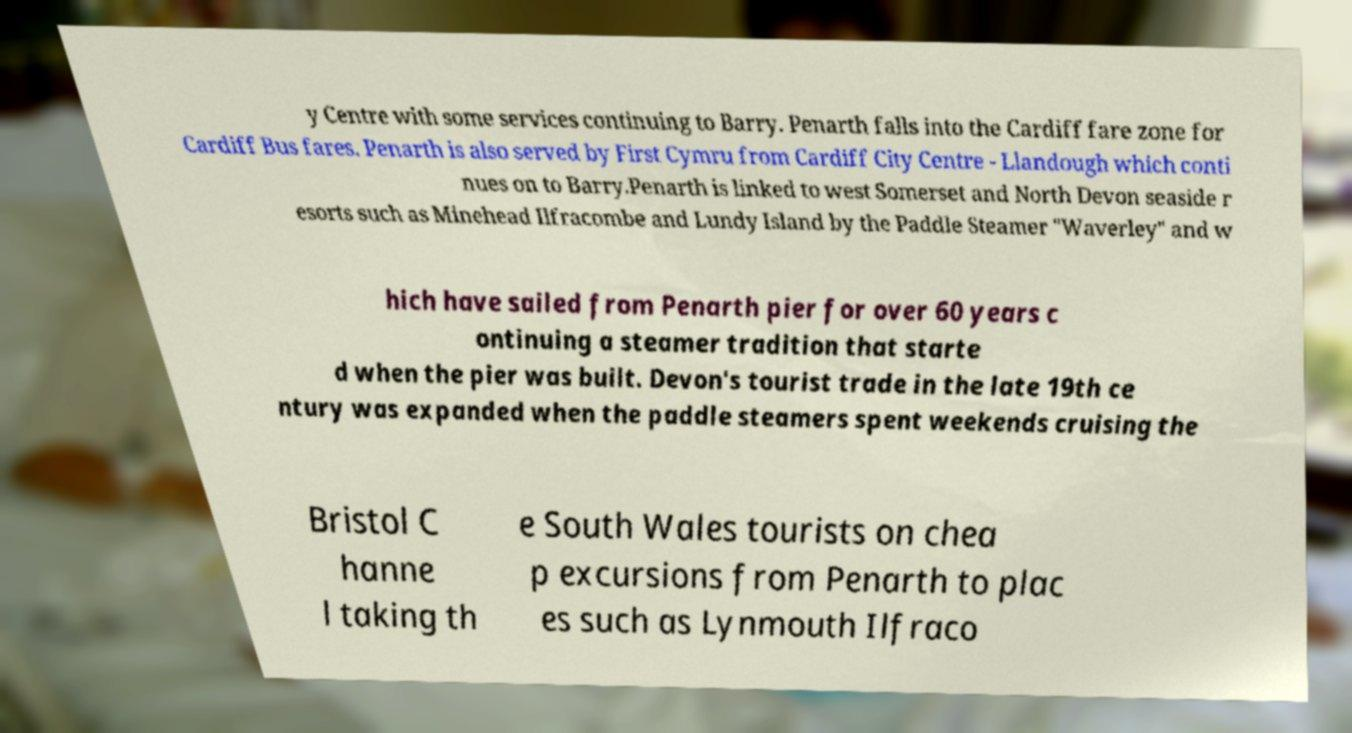Could you extract and type out the text from this image? y Centre with some services continuing to Barry. Penarth falls into the Cardiff fare zone for Cardiff Bus fares. Penarth is also served by First Cymru from Cardiff City Centre - Llandough which conti nues on to Barry.Penarth is linked to west Somerset and North Devon seaside r esorts such as Minehead Ilfracombe and Lundy Island by the Paddle Steamer "Waverley" and w hich have sailed from Penarth pier for over 60 years c ontinuing a steamer tradition that starte d when the pier was built. Devon's tourist trade in the late 19th ce ntury was expanded when the paddle steamers spent weekends cruising the Bristol C hanne l taking th e South Wales tourists on chea p excursions from Penarth to plac es such as Lynmouth Ilfraco 